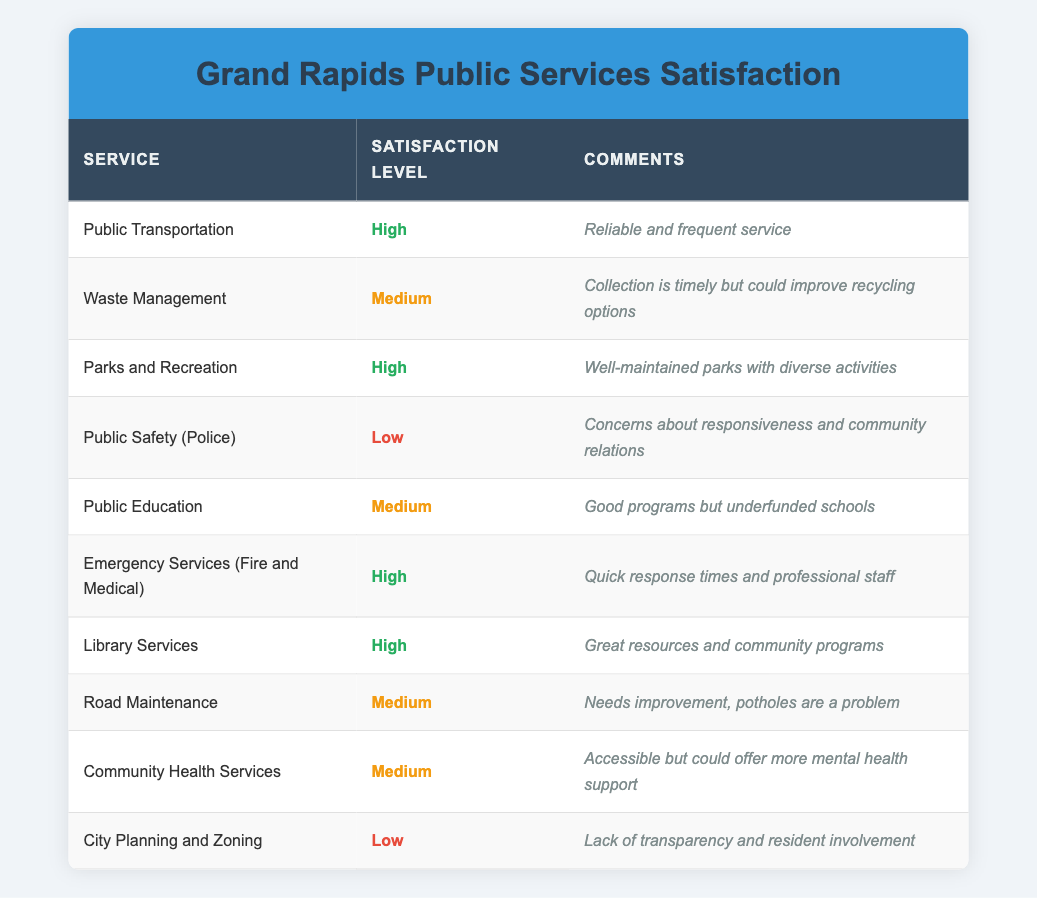What is the satisfaction level for Library Services? The satisfaction level for Library Services is clearly listed in the table under the respective service, which shows it as "High."
Answer: High How many services are rated with Medium satisfaction levels? By counting the entries in the satisfaction level column, I see that there are four services rated as Medium: Waste Management, Public Education, Road Maintenance, and Community Health Services.
Answer: 4 Is Public Transportation rated as Low satisfaction? The satisfaction level for Public Transportation is listed as "High" in the table, so it is not rated as Low.
Answer: No Which service has the lowest satisfaction rating? The table indicates that Public Safety (Police) and City Planning and Zoning are both rated as "Low." Both services feature comments expressing significant concerns, but since the question asks for just one, I can choose Public Safety (Police).
Answer: Public Safety (Police) What percentage of the services listed have a High satisfaction rating? There are 10 total services, and 5 of them are rated as High. To calculate the percentage, I divide 5 by 10 and then multiply by 100, resulting in 50%.
Answer: 50% Which service received comments about the need for improved recycling options? In Waste Management, the comments specifically mention that "Collection is timely but could improve recycling options." This directly indicates the service that received such feedback.
Answer: Waste Management Is there a service that is rated High but also has comments addressing areas of improvement? The Emergency Services (Fire and Medical) service is rated as High, but the comments highlight that while response times are quick and staff is professional, there's always room for improvement in services. However, this service does not explicitly indicate a need for improvement; thus, the answer is no.
Answer: No List the services that have both High satisfaction and positive comments. The services with High satisfaction ratings and positive comments are Public Transportation, Parks and Recreation, Emergency Services (Fire and Medical), and Library Services. Each of these entries has constructive comments, reflecting a strong community appreciation.
Answer: Public Transportation, Parks and Recreation, Emergency Services (Fire and Medical), Library Services 